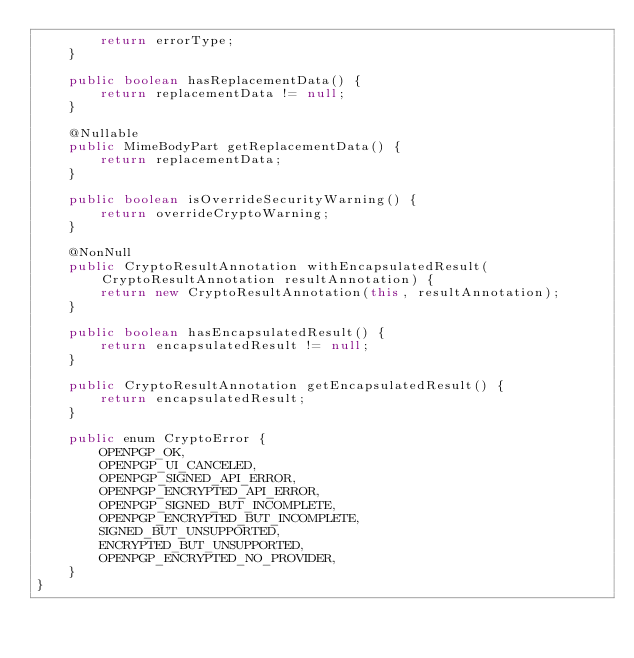Convert code to text. <code><loc_0><loc_0><loc_500><loc_500><_Java_>        return errorType;
    }

    public boolean hasReplacementData() {
        return replacementData != null;
    }

    @Nullable
    public MimeBodyPart getReplacementData() {
        return replacementData;
    }

    public boolean isOverrideSecurityWarning() {
        return overrideCryptoWarning;
    }

    @NonNull
    public CryptoResultAnnotation withEncapsulatedResult(CryptoResultAnnotation resultAnnotation) {
        return new CryptoResultAnnotation(this, resultAnnotation);
    }

    public boolean hasEncapsulatedResult() {
        return encapsulatedResult != null;
    }

    public CryptoResultAnnotation getEncapsulatedResult() {
        return encapsulatedResult;
    }

    public enum CryptoError {
        OPENPGP_OK,
        OPENPGP_UI_CANCELED,
        OPENPGP_SIGNED_API_ERROR,
        OPENPGP_ENCRYPTED_API_ERROR,
        OPENPGP_SIGNED_BUT_INCOMPLETE,
        OPENPGP_ENCRYPTED_BUT_INCOMPLETE,
        SIGNED_BUT_UNSUPPORTED,
        ENCRYPTED_BUT_UNSUPPORTED,
        OPENPGP_ENCRYPTED_NO_PROVIDER,
    }
}
</code> 